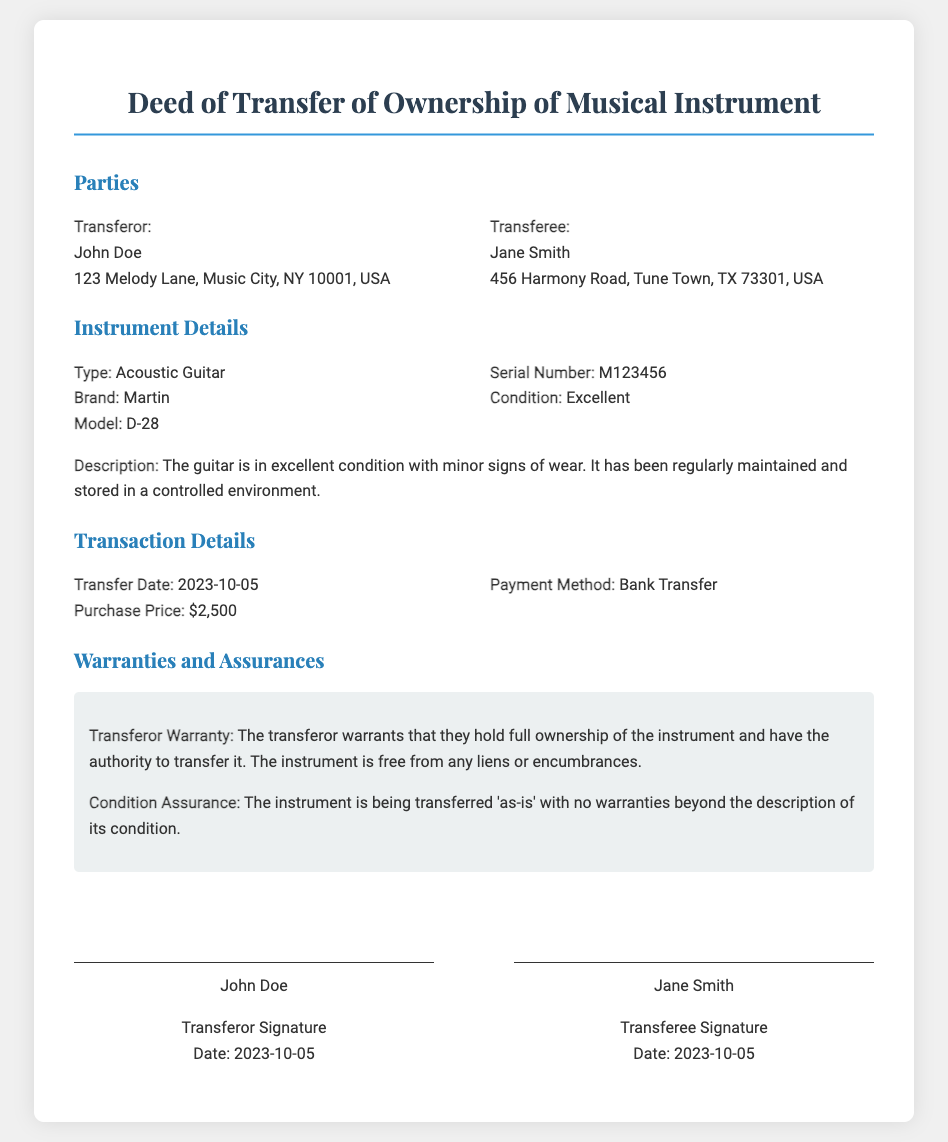What is the name of the transferor? The transferor's name is stated in the parties section of the document.
Answer: John Doe What is the brand of the instrument? The brand of the instrument is mentioned in the instrument details section.
Answer: Martin What is the condition of the instrument? The condition of the instrument is specifically noted in the instrument details section.
Answer: Excellent What is the purchase price of the musical instrument? The purchase price is listed in the transaction details section of the document.
Answer: $2,500 What date was the transfer completed? The transfer date is provided within the transaction details section.
Answer: 2023-10-05 Who signed the deed as the transferee? The signature section indicates who signed as the transferee.
Answer: Jane Smith What type of guitar is being transferred? The type of the instrument is explicitly mentioned in the instrument details.
Answer: Acoustic Guitar Is there any warranty for the condition of the instrument? The document specifies whether there are any warranties or assurances regarding the instrument condition.
Answer: No 